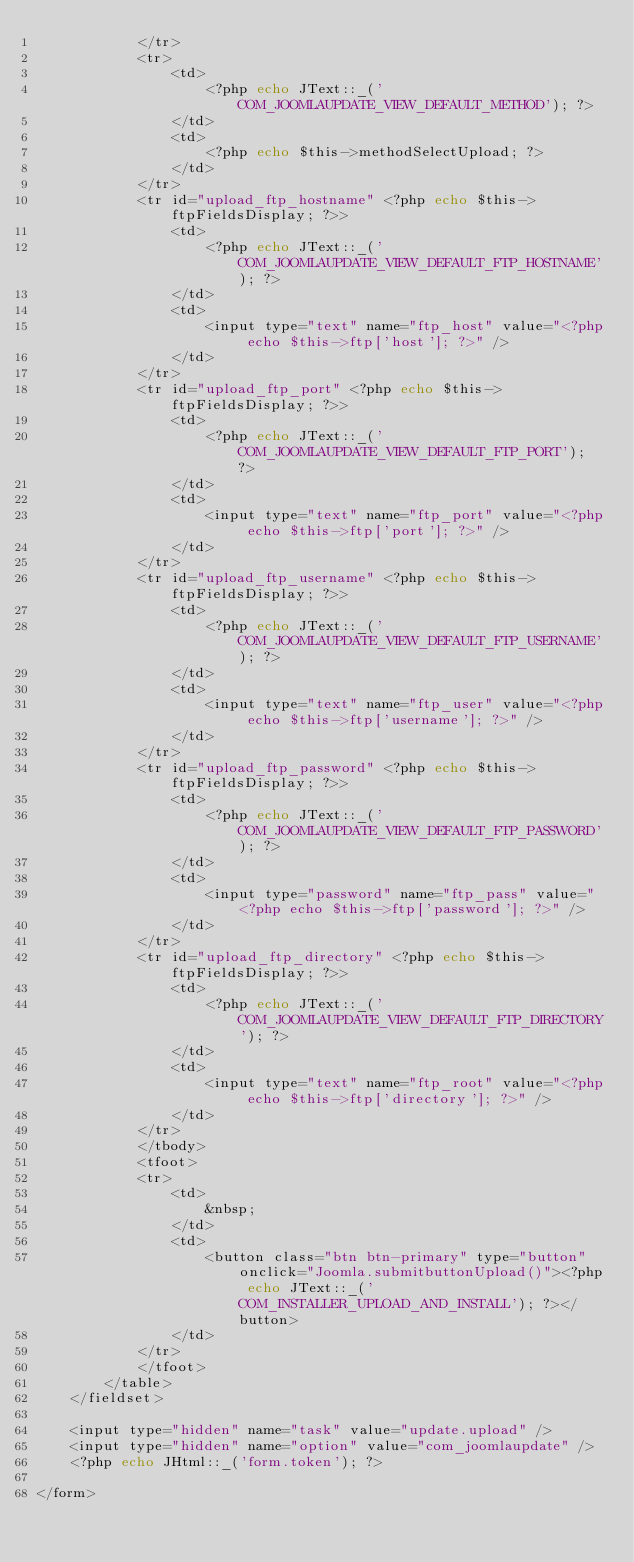Convert code to text. <code><loc_0><loc_0><loc_500><loc_500><_PHP_>			</tr>
			<tr>
				<td>
					<?php echo JText::_('COM_JOOMLAUPDATE_VIEW_DEFAULT_METHOD'); ?>
				</td>
				<td>
					<?php echo $this->methodSelectUpload; ?>
				</td>
			</tr>
			<tr id="upload_ftp_hostname" <?php echo $this->ftpFieldsDisplay; ?>>
				<td>
					<?php echo JText::_('COM_JOOMLAUPDATE_VIEW_DEFAULT_FTP_HOSTNAME'); ?>
				</td>
				<td>
					<input type="text" name="ftp_host" value="<?php echo $this->ftp['host']; ?>" />
				</td>
			</tr>
			<tr id="upload_ftp_port" <?php echo $this->ftpFieldsDisplay; ?>>
				<td>
					<?php echo JText::_('COM_JOOMLAUPDATE_VIEW_DEFAULT_FTP_PORT'); ?>
				</td>
				<td>
					<input type="text" name="ftp_port" value="<?php echo $this->ftp['port']; ?>" />
				</td>
			</tr>
			<tr id="upload_ftp_username" <?php echo $this->ftpFieldsDisplay; ?>>
				<td>
					<?php echo JText::_('COM_JOOMLAUPDATE_VIEW_DEFAULT_FTP_USERNAME'); ?>
				</td>
				<td>
					<input type="text" name="ftp_user" value="<?php echo $this->ftp['username']; ?>" />
				</td>
			</tr>
			<tr id="upload_ftp_password" <?php echo $this->ftpFieldsDisplay; ?>>
				<td>
					<?php echo JText::_('COM_JOOMLAUPDATE_VIEW_DEFAULT_FTP_PASSWORD'); ?>
				</td>
				<td>
					<input type="password" name="ftp_pass" value="<?php echo $this->ftp['password']; ?>" />
				</td>
			</tr>
			<tr id="upload_ftp_directory" <?php echo $this->ftpFieldsDisplay; ?>>
				<td>
					<?php echo JText::_('COM_JOOMLAUPDATE_VIEW_DEFAULT_FTP_DIRECTORY'); ?>
				</td>
				<td>
					<input type="text" name="ftp_root" value="<?php echo $this->ftp['directory']; ?>" />
				</td>
			</tr>
			</tbody>
			<tfoot>
			<tr>
				<td>
					&nbsp;
				</td>
				<td>
					<button class="btn btn-primary" type="button" onclick="Joomla.submitbuttonUpload()"><?php echo JText::_('COM_INSTALLER_UPLOAD_AND_INSTALL'); ?></button>
				</td>
			</tr>
			</tfoot>
		</table>
	</fieldset>

	<input type="hidden" name="task" value="update.upload" />
	<input type="hidden" name="option" value="com_joomlaupdate" />
	<?php echo JHtml::_('form.token'); ?>

</form>
</code> 